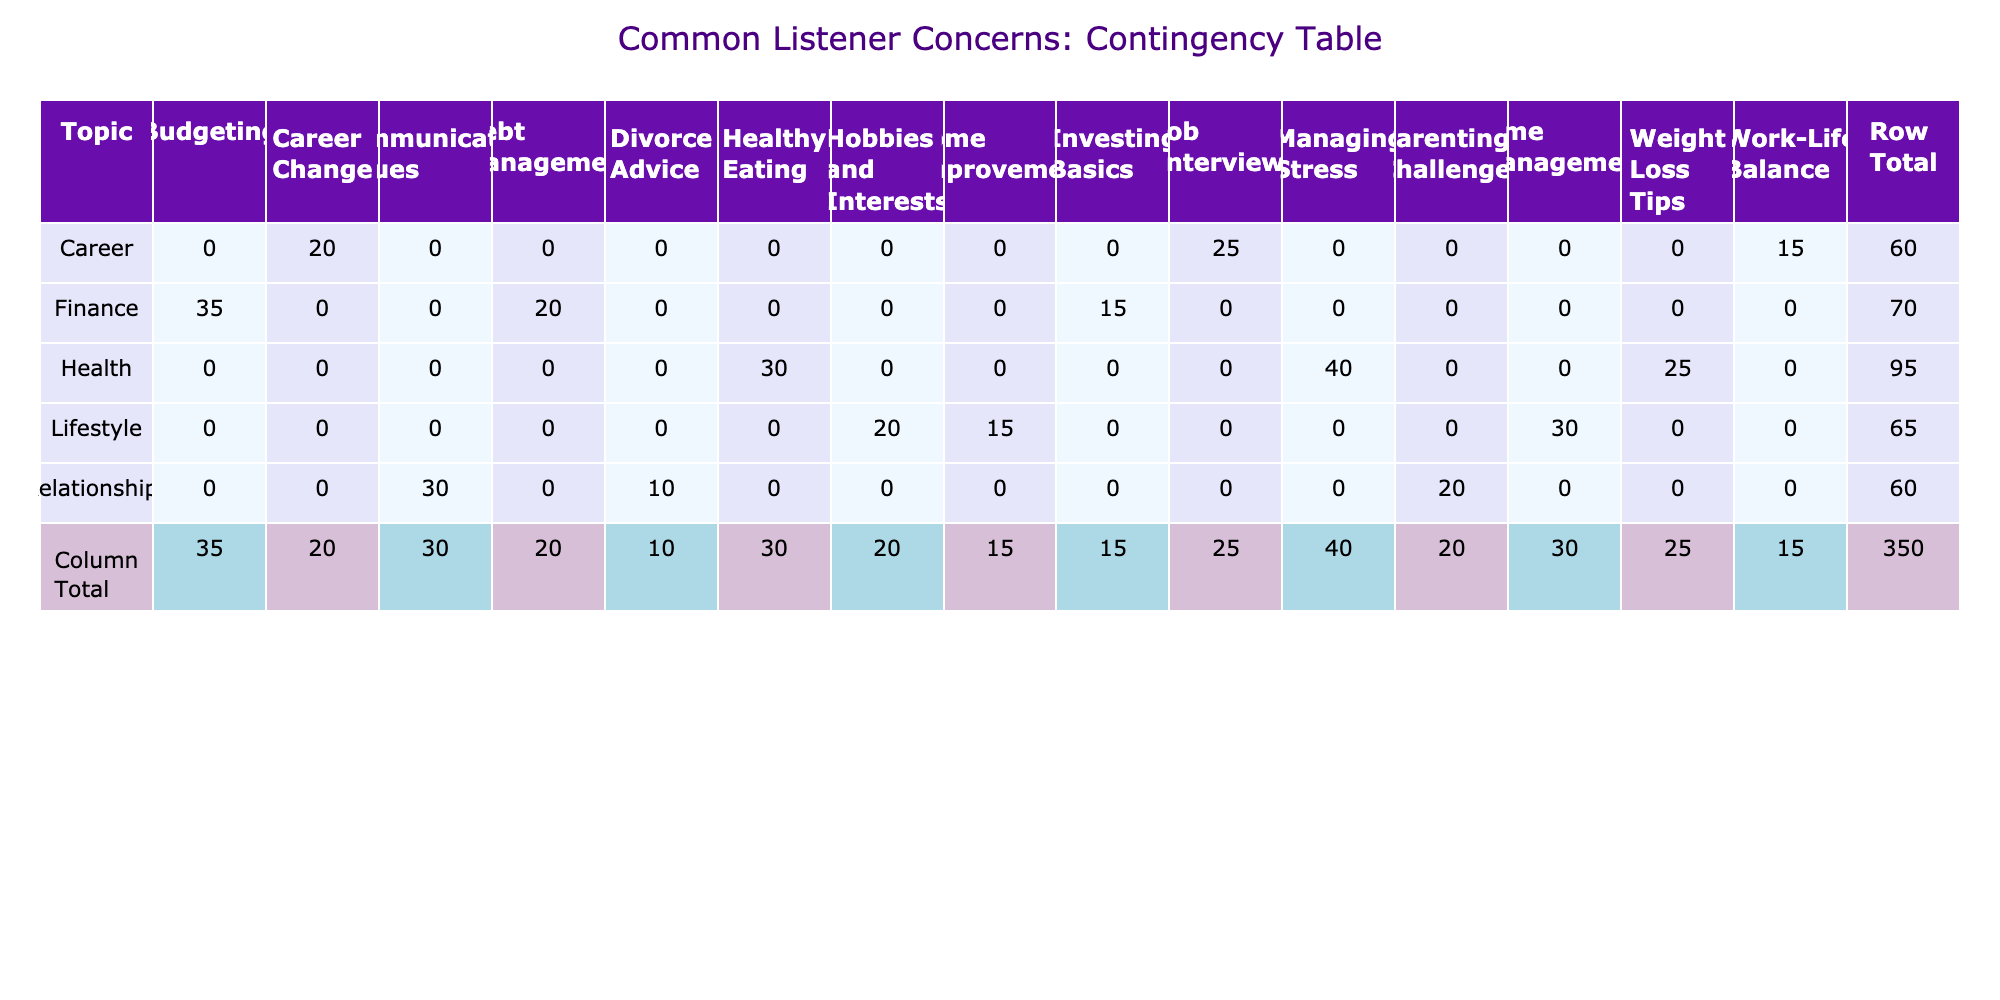What is the call-in frequency for "Healthy Eating"? The table shows that the call-in frequency for "Healthy Eating" under the "Health" topic is 30.
Answer: 30 What are the total call-in frequencies for all concerns under the "Finance" topic? To find the total, we add the call-in frequencies for each concern under "Finance": Budgeting (35) + Debt Management (20) + Investing Basics (15) = 70.
Answer: 70 Is there a concern listed under "Relationships" that has a call-in frequency greater than 25? The table indicates that "Communication Issues" has a call-in frequency of 30, which is greater than 25, confirming that yes, there is such a concern.
Answer: Yes Which concern under "Career" has the lowest call-in frequency? Looking at the "Career" section, we see Job Interviews (25), Work-Life Balance (15), and Career Change (20). The lowest is Work-Life Balance with a frequency of 15.
Answer: Work-Life Balance What is the combined call-in frequency for "Parenting Challenges" and "Divorce Advice"? The call-in frequency for "Parenting Challenges" is 20 and for "Divorce Advice" is 10. Adding these together gives 20 + 10 = 30.
Answer: 30 Which topic has the highest total call-in frequency? We will calculate the total for each topic: Health (40 + 25 + 30 = 95), Finance (35 + 20 + 15 = 70), Relationships (30 + 10 + 20 = 60), Career (25 + 15 + 20 = 60), Lifestyle (30 + 20 + 15 = 65). The highest is Health with a total of 95.
Answer: Health How many concerns under "Lifestyle" have a call-in frequency of 20 or less? The "Lifestyle" concerns are Time Management (30), Hobbies and Interests (20), and Home Improvement (15). Only Hobbies and Interests and Home Improvement have frequencies of 20 or less, totaling 2 concerns.
Answer: 2 Is the call-in frequency for "Debt Management" higher than that for "Career Change"? Debt Management has a frequency of 20 and Career Change has 20 as well. They are equal, so the answer is no.
Answer: No What is the average call-in frequency across all topics? Summing all the frequencies: 40 + 25 + 30 + 35 + 20 + 15 + 30 + 10 + 20 + 25 + 15 + 20 + 30 + 20 + 15 =  325. There are 15 data points total, so the average is 325/15 = 21.67.
Answer: 21.67 